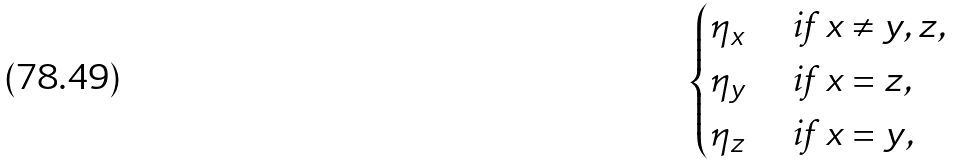Convert formula to latex. <formula><loc_0><loc_0><loc_500><loc_500>\begin{cases} \eta _ { x } & \text { if } x \neq y , z , \\ \eta _ { y } & \text { if } x = z , \\ \eta _ { z } & \text { if } x = y , \end{cases}</formula> 